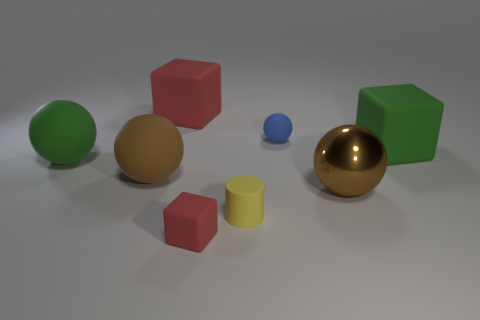The rubber thing that is the same color as the shiny object is what size?
Provide a succinct answer. Large. There is a object that is the same color as the tiny matte cube; what material is it?
Provide a short and direct response. Rubber. Are there any big matte cubes that have the same color as the big metallic ball?
Ensure brevity in your answer.  No. Is there a green rubber block that is right of the green object that is on the right side of the tiny yellow object?
Your answer should be very brief. No. Are there any large gray cubes made of the same material as the tiny red cube?
Your answer should be very brief. No. What material is the green thing that is behind the green matte thing on the left side of the metal ball?
Give a very brief answer. Rubber. What material is the object that is both in front of the large green sphere and on the left side of the large red matte thing?
Your response must be concise. Rubber. Are there the same number of blue rubber things behind the small ball and big brown spheres?
Provide a succinct answer. No. What number of large green objects have the same shape as the yellow thing?
Your answer should be very brief. 0. There is a matte ball that is right of the red block that is in front of the red rubber object behind the big brown matte sphere; how big is it?
Offer a very short reply. Small. 